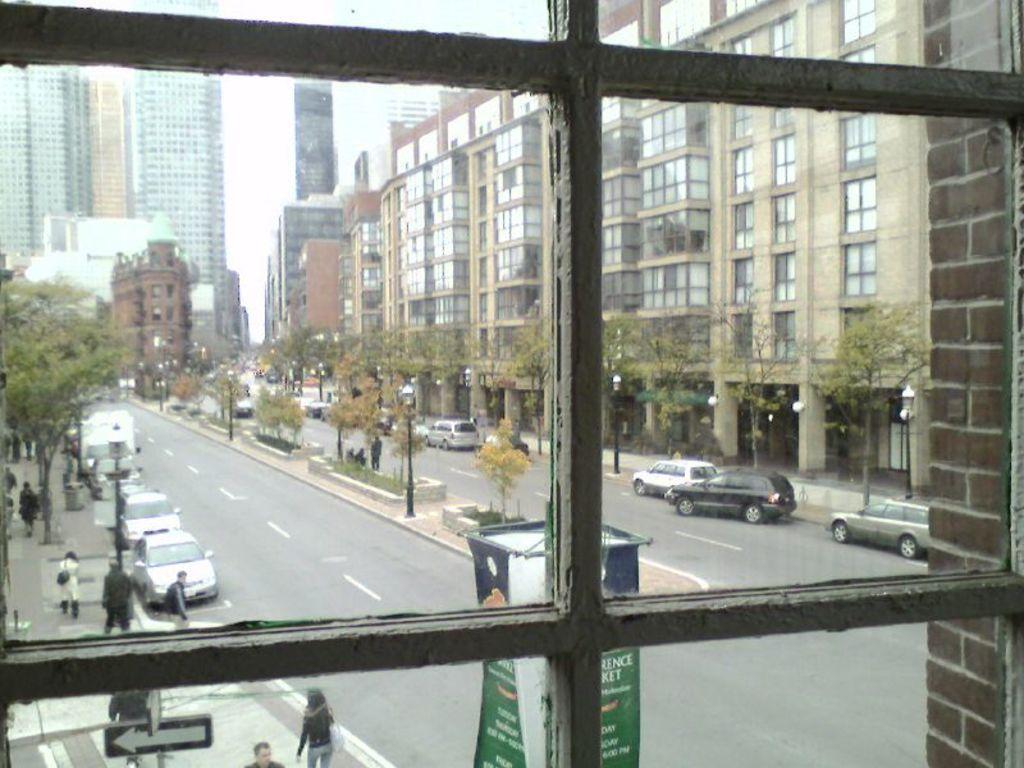Can you describe this image briefly? In this picture we can see group of people, few vehicles, trees and buildings, and we can see few poles, lights and hoardings. 